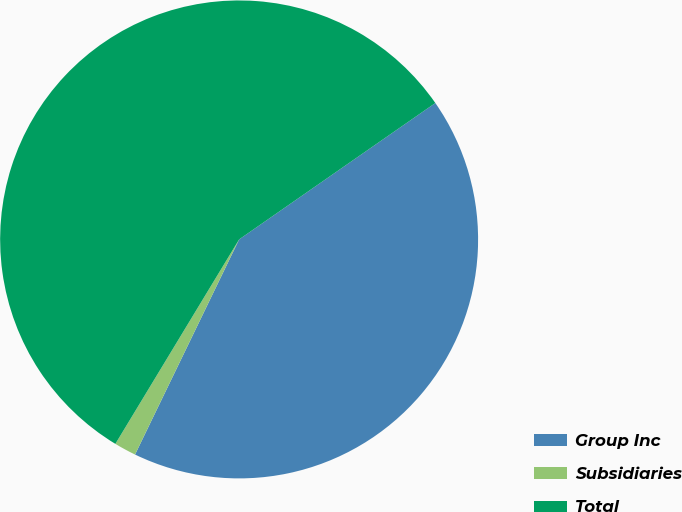Convert chart. <chart><loc_0><loc_0><loc_500><loc_500><pie_chart><fcel>Group Inc<fcel>Subsidiaries<fcel>Total<nl><fcel>41.84%<fcel>1.49%<fcel>56.67%<nl></chart> 